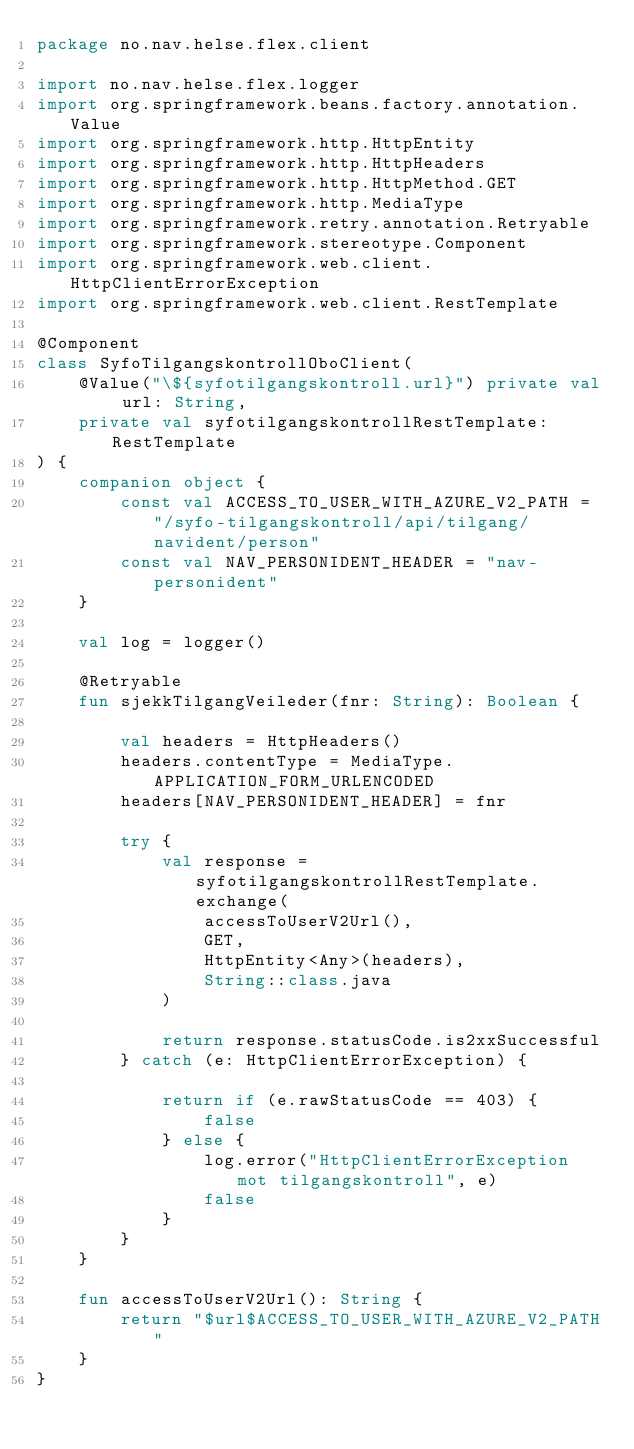Convert code to text. <code><loc_0><loc_0><loc_500><loc_500><_Kotlin_>package no.nav.helse.flex.client

import no.nav.helse.flex.logger
import org.springframework.beans.factory.annotation.Value
import org.springframework.http.HttpEntity
import org.springframework.http.HttpHeaders
import org.springframework.http.HttpMethod.GET
import org.springframework.http.MediaType
import org.springframework.retry.annotation.Retryable
import org.springframework.stereotype.Component
import org.springframework.web.client.HttpClientErrorException
import org.springframework.web.client.RestTemplate

@Component
class SyfoTilgangskontrollOboClient(
    @Value("\${syfotilgangskontroll.url}") private val url: String,
    private val syfotilgangskontrollRestTemplate: RestTemplate
) {
    companion object {
        const val ACCESS_TO_USER_WITH_AZURE_V2_PATH = "/syfo-tilgangskontroll/api/tilgang/navident/person"
        const val NAV_PERSONIDENT_HEADER = "nav-personident"
    }

    val log = logger()

    @Retryable
    fun sjekkTilgangVeileder(fnr: String): Boolean {

        val headers = HttpHeaders()
        headers.contentType = MediaType.APPLICATION_FORM_URLENCODED
        headers[NAV_PERSONIDENT_HEADER] = fnr

        try {
            val response = syfotilgangskontrollRestTemplate.exchange(
                accessToUserV2Url(),
                GET,
                HttpEntity<Any>(headers),
                String::class.java
            )

            return response.statusCode.is2xxSuccessful
        } catch (e: HttpClientErrorException) {

            return if (e.rawStatusCode == 403) {
                false
            } else {
                log.error("HttpClientErrorException mot tilgangskontroll", e)
                false
            }
        }
    }

    fun accessToUserV2Url(): String {
        return "$url$ACCESS_TO_USER_WITH_AZURE_V2_PATH"
    }
}
</code> 